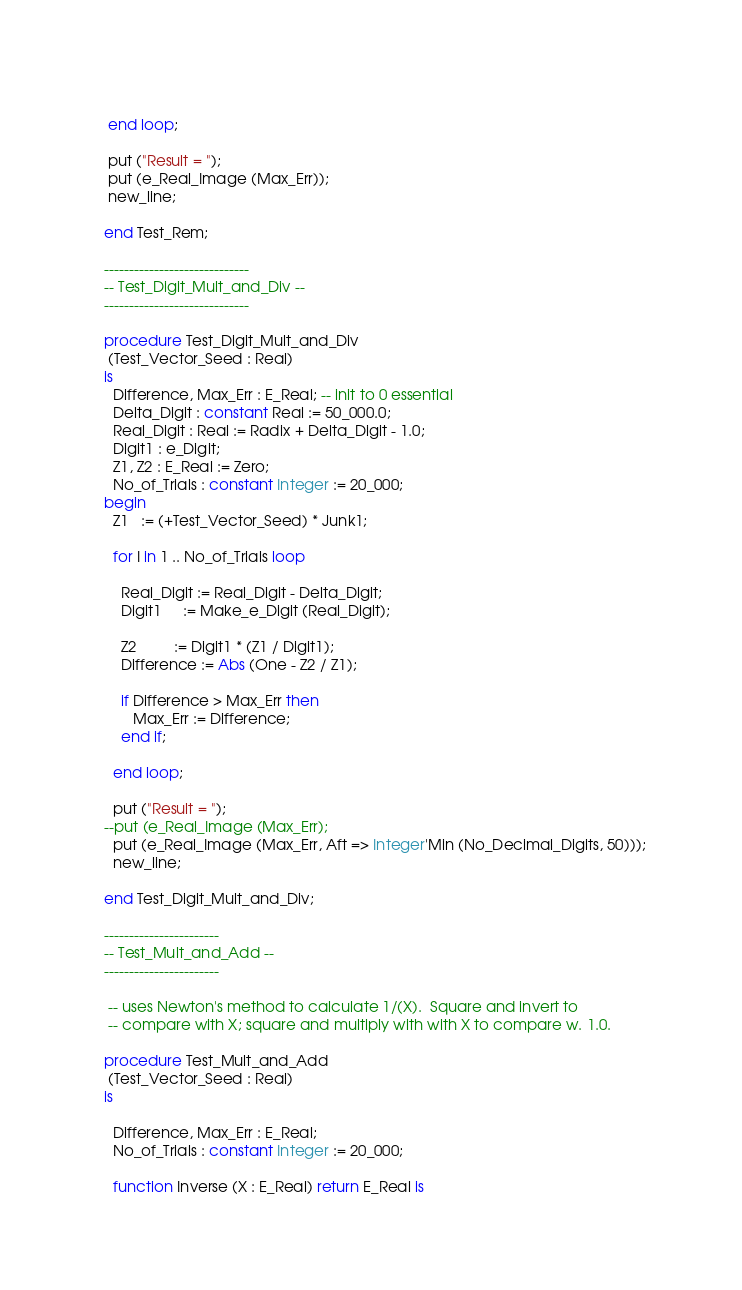<code> <loc_0><loc_0><loc_500><loc_500><_Ada_>       
   end loop;
   
   put ("Result = "); 
   put (e_Real_Image (Max_Err));
   new_line;
   
  end Test_Rem;

  -----------------------------
  -- Test_Digit_Mult_and_Div --
  -----------------------------
  
  procedure Test_Digit_Mult_and_Div 
   (Test_Vector_Seed : Real) 
  is 
    Difference, Max_Err : E_Real; -- init to 0 essential
    Delta_Digit : constant Real := 50_000.0;
    Real_Digit : Real := Radix + Delta_Digit - 1.0;
    Digit1 : e_Digit;
    Z1, Z2 : E_Real := Zero;
    No_of_Trials : constant Integer := 20_000;
  begin
    Z1   := (+Test_Vector_Seed) * Junk1;
    
    for I in 1 .. No_of_Trials loop

      Real_Digit := Real_Digit - Delta_Digit;
      Digit1     := Make_e_Digit (Real_Digit);

      Z2         := Digit1 * (Z1 / Digit1);
      Difference := Abs (One - Z2 / Z1);

      if Difference > Max_Err then
         Max_Err := Difference;
      end if;
       
    end loop;
   
    put ("Result = "); 
  --put (e_Real_Image (Max_Err);
    put (e_Real_Image (Max_Err, Aft => Integer'Min (No_Decimal_Digits, 50)));
    new_line;
   
  end Test_Digit_Mult_and_Div;
  
  -----------------------
  -- Test_Mult_and_Add --
  -----------------------

   -- uses Newton's method to calculate 1/(X).  Square and invert to
   -- compare with X; square and multiply with with X to compare w. 1.0.

  procedure Test_Mult_and_Add 
   (Test_Vector_Seed : Real) 
  is 
    
    Difference, Max_Err : E_Real;
    No_of_Trials : constant Integer := 20_000;

    function Inverse (X : E_Real) return E_Real is</code> 